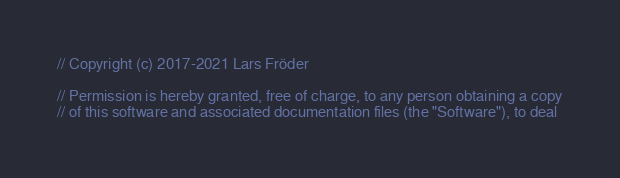Convert code to text. <code><loc_0><loc_0><loc_500><loc_500><_ObjectiveC_>// Copyright (c) 2017-2021 Lars Fröder

// Permission is hereby granted, free of charge, to any person obtaining a copy
// of this software and associated documentation files (the "Software"), to deal</code> 